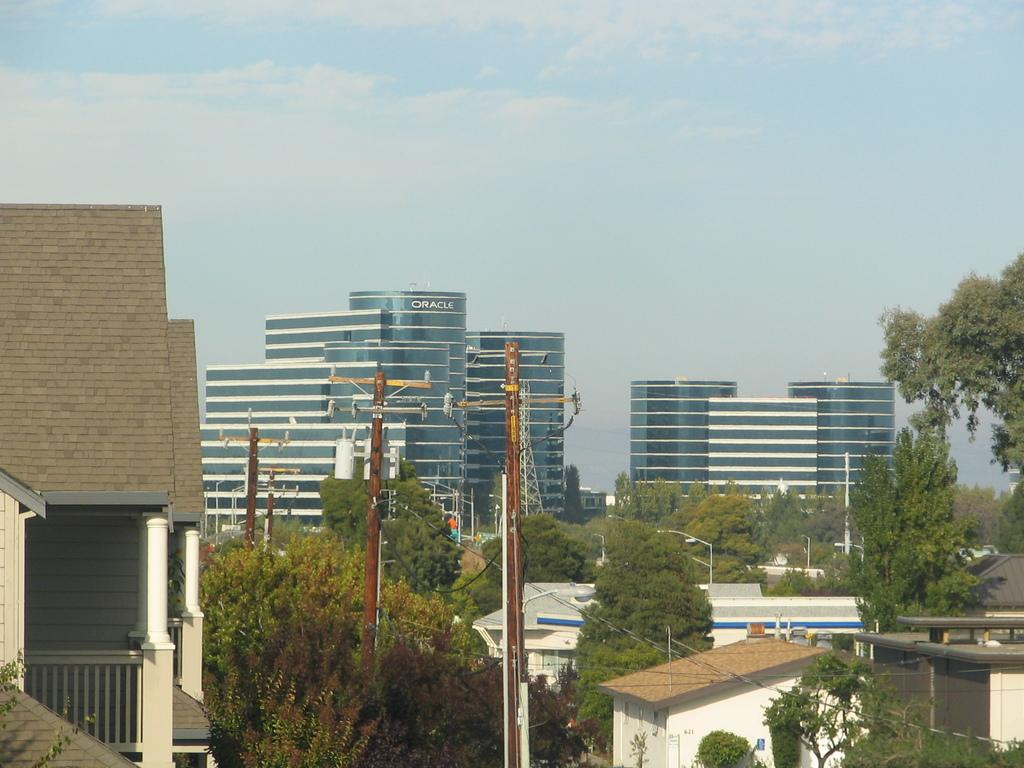Provide a one-sentence caption for the provided image. The Oracle building is shown in the distance behind the telephone poles and houses. 